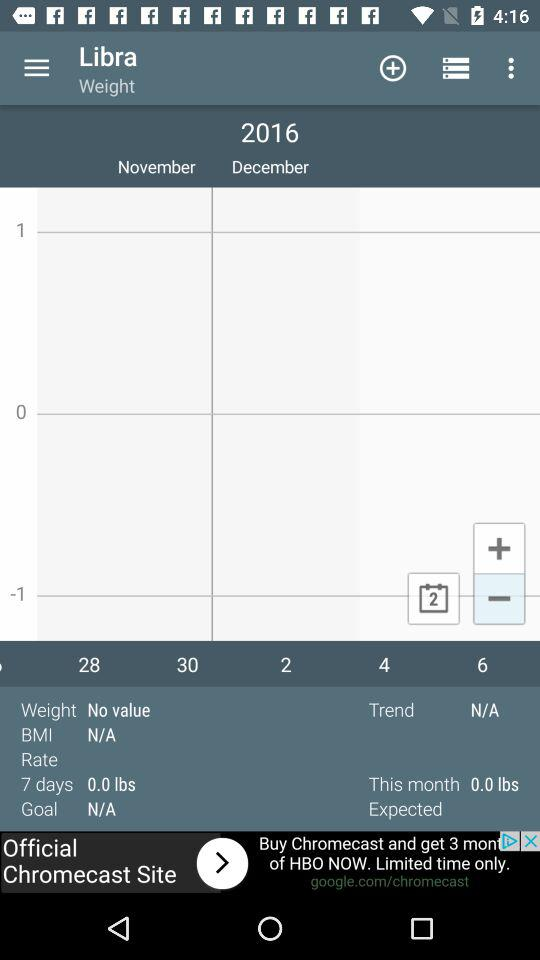What is the user name? The user name is Libra. 